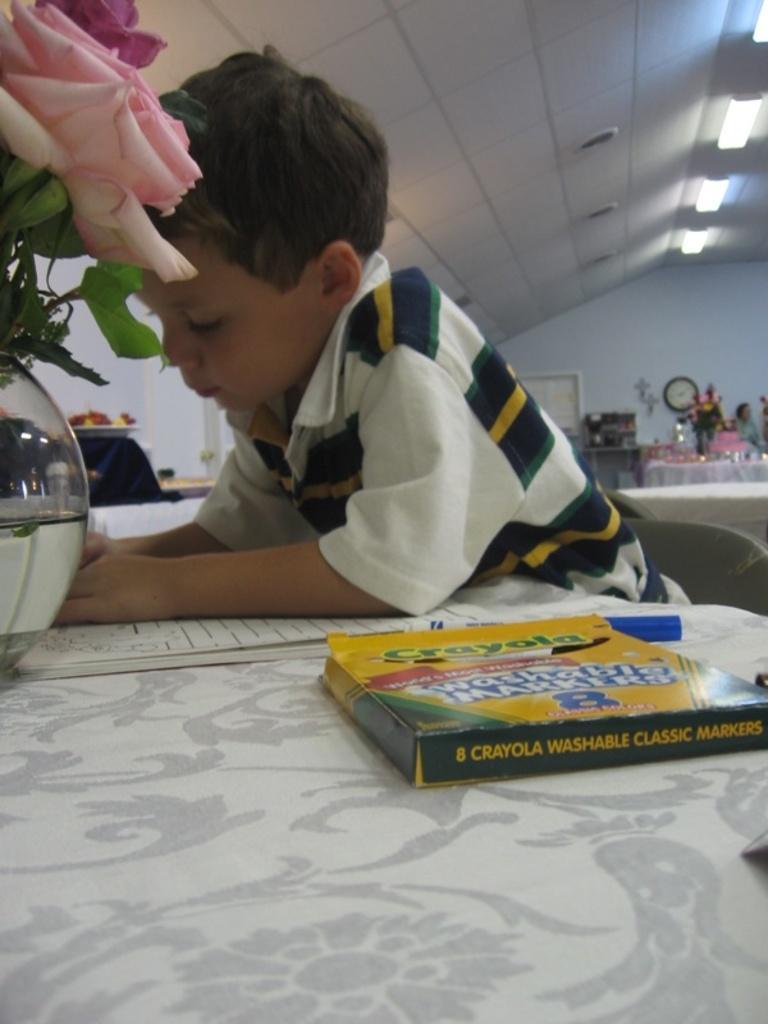Could you give a brief overview of what you see in this image? In this picture we can see a kid is seated on the chair, in front of him we can find books, flower vase, sketches on the table, in the background we can see couple of lights. 